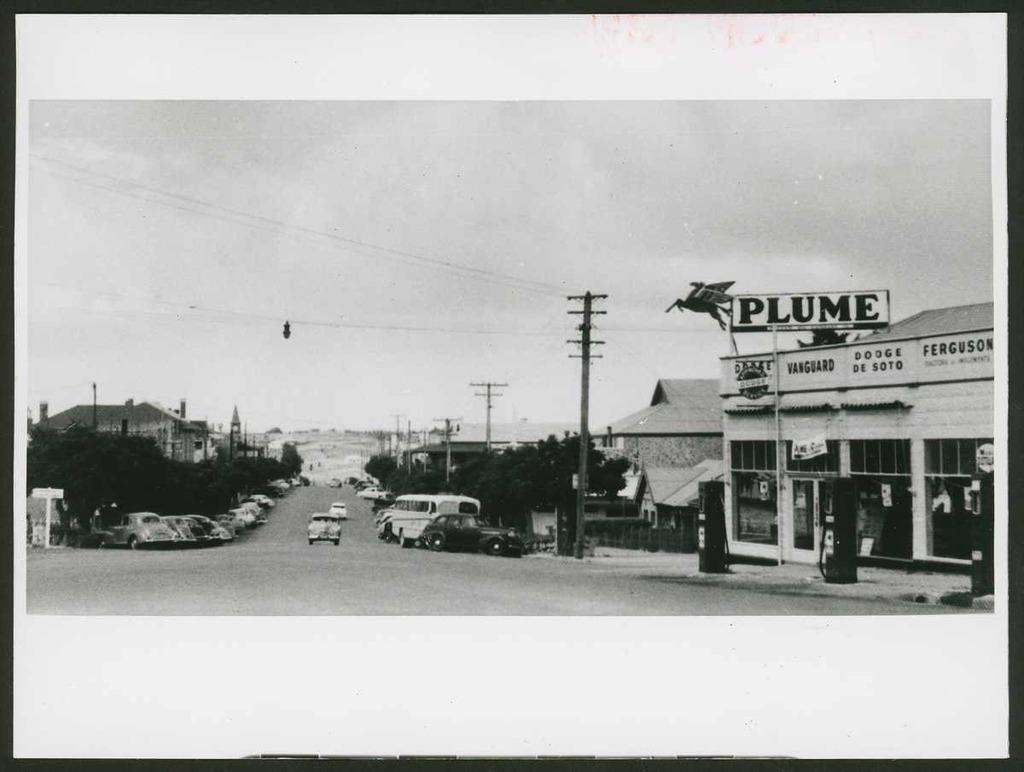What is the name of this restaurant?
Your answer should be compact. Plume. 